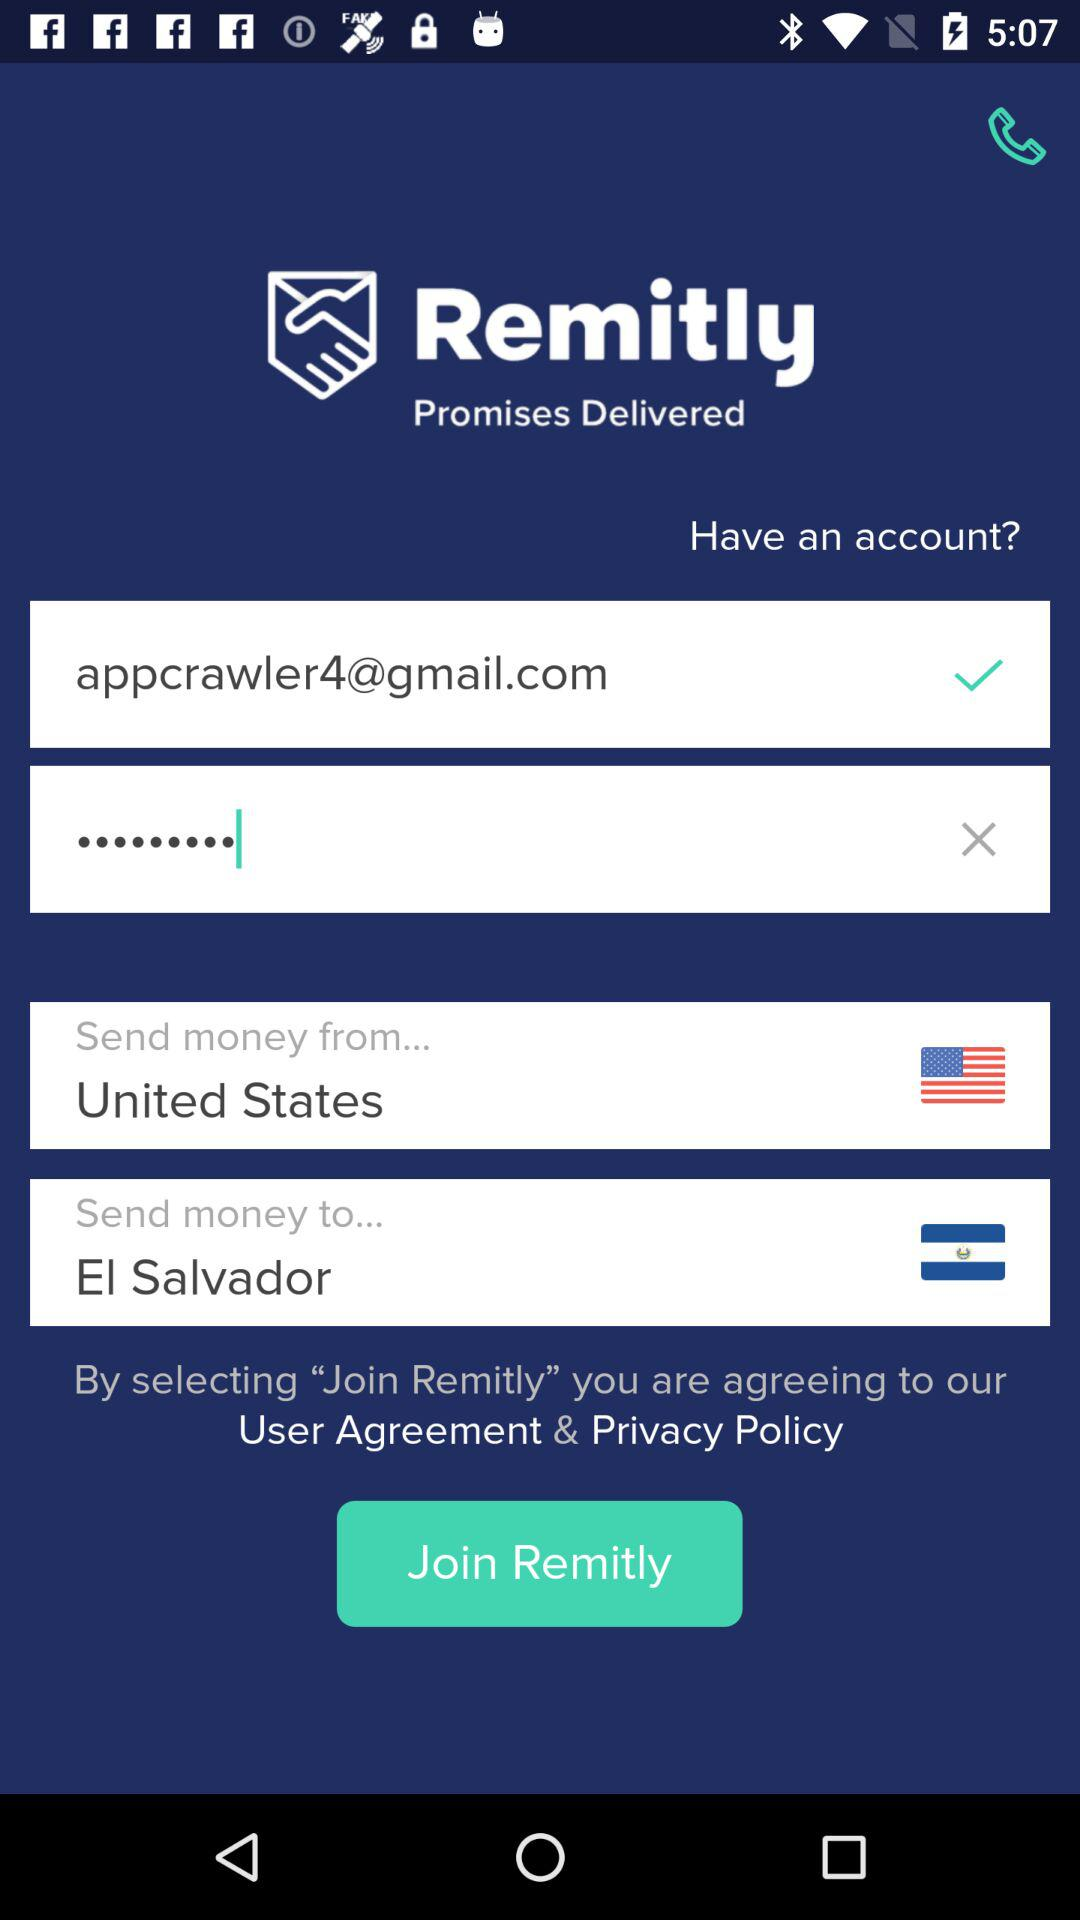How many text inputs have a flag next to them?
Answer the question using a single word or phrase. 2 